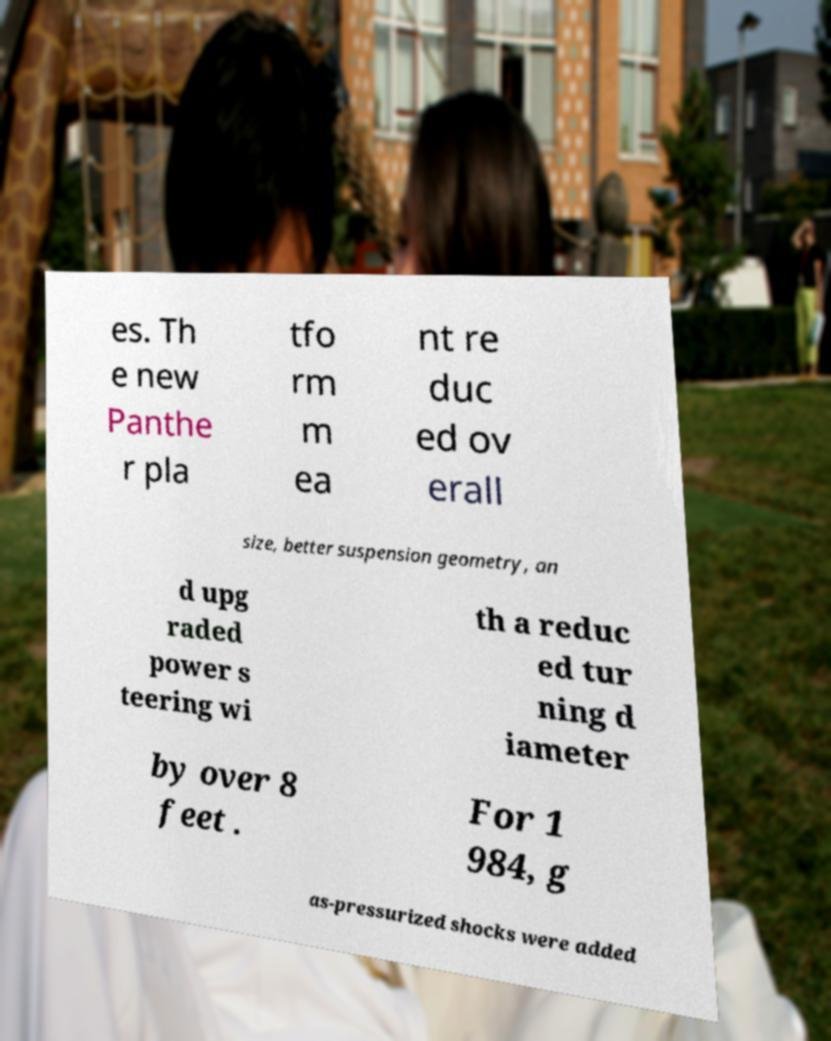Please identify and transcribe the text found in this image. es. Th e new Panthe r pla tfo rm m ea nt re duc ed ov erall size, better suspension geometry, an d upg raded power s teering wi th a reduc ed tur ning d iameter by over 8 feet . For 1 984, g as-pressurized shocks were added 